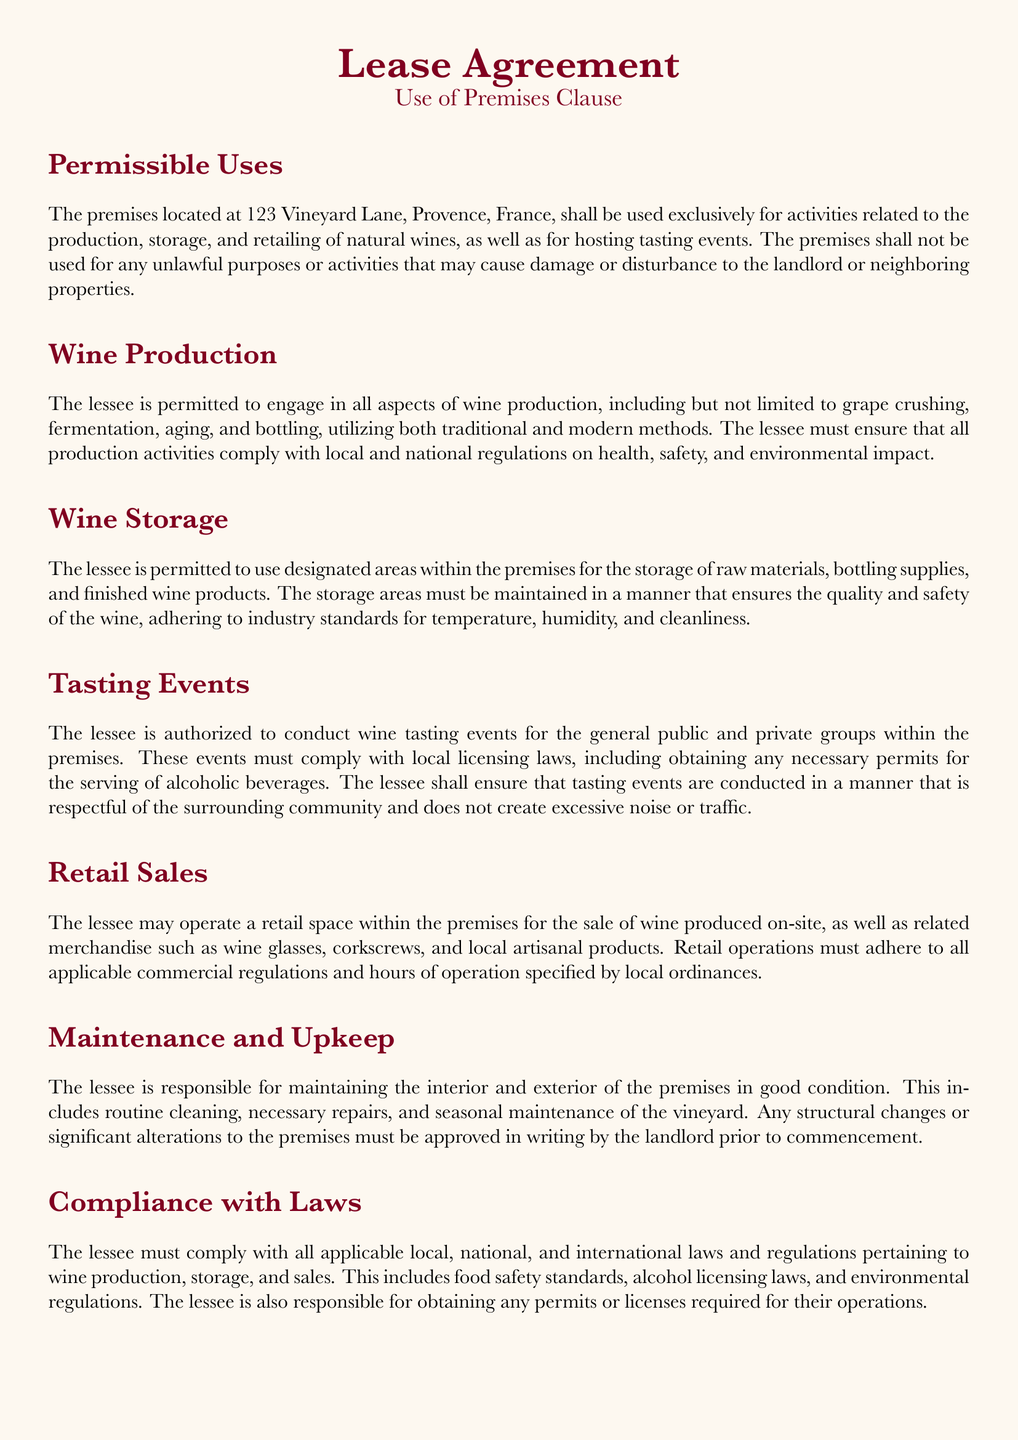What is the address of the premises? The address is specified at the beginning of the document.
Answer: 123 Vineyard Lane, Provence, France What activities are prohibited on the premises? The document states that the premises must not be used for any unlawful purposes or activities.
Answer: Unlawful purposes What type of wine production methods are allowed? The document mentions that both traditional and modern methods can be used for wine production.
Answer: Traditional and modern methods What is required to conduct tasting events? The document states that compliance with local licensing laws and permits for serving alcoholic beverages is necessary.
Answer: Necessary permits Who is responsible for maintaining the premises? The lease agreement specifies that the lessee is responsible for maintaining the premises in good condition.
Answer: Lessee What must the lessee ensure regarding storage areas? The document requires that the storage areas must ensure the quality and safety of the wine.
Answer: Quality and safety of the wine What activities can the lessee conduct on the premises? The document lists several activities, including production, storage, retailing, and tasting events related to natural wines.
Answer: Production, storage, retailing, tasting events What types of products can be sold in the retail space? The lease specifies that the lessee may sell wine produced on-site and related merchandise.
Answer: Wine and related merchandise 